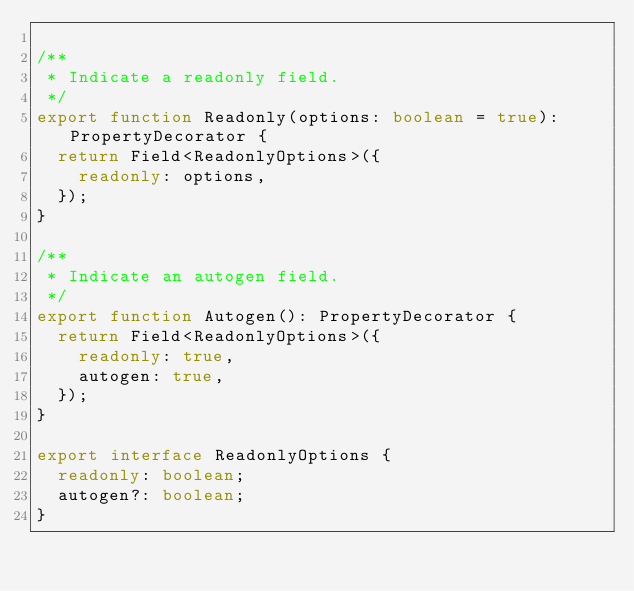<code> <loc_0><loc_0><loc_500><loc_500><_TypeScript_>
/**
 * Indicate a readonly field.
 */
export function Readonly(options: boolean = true): PropertyDecorator {
  return Field<ReadonlyOptions>({
    readonly: options,
  });
}

/**
 * Indicate an autogen field.
 */
export function Autogen(): PropertyDecorator {
  return Field<ReadonlyOptions>({
    readonly: true,
    autogen: true,
  });
}

export interface ReadonlyOptions {
  readonly: boolean;
  autogen?: boolean;
}
</code> 